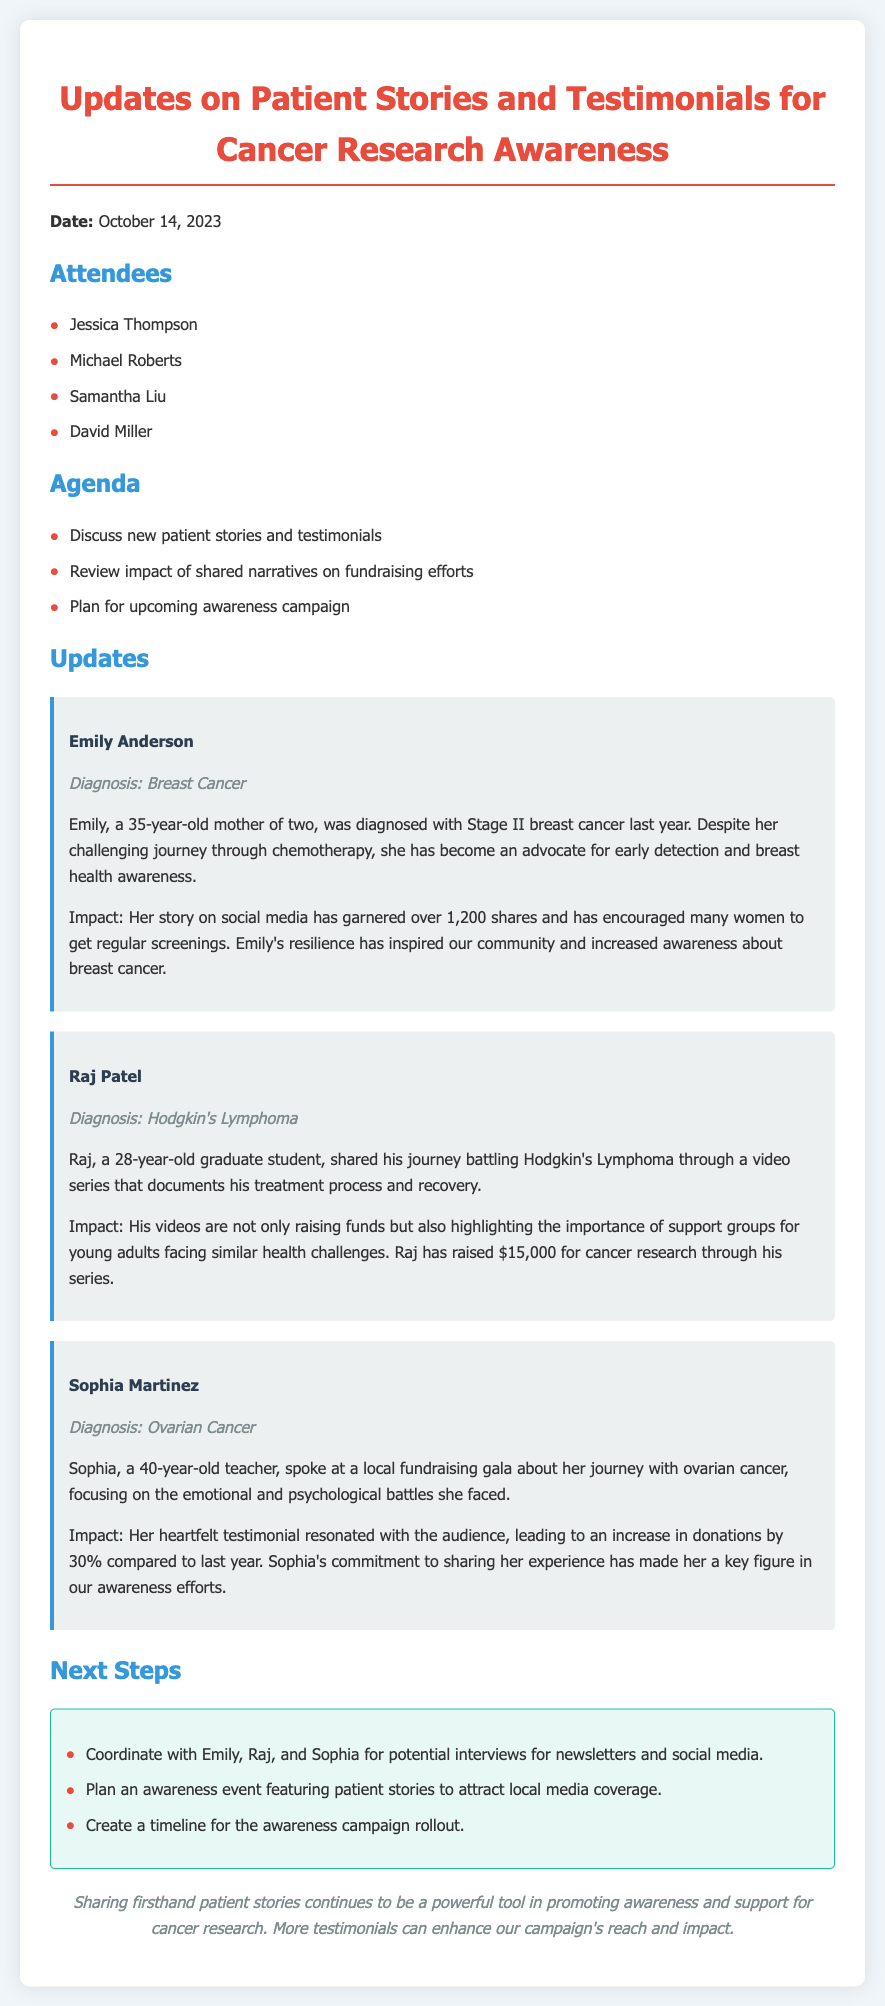What is the date of the meeting? The date of the meeting is mentioned at the beginning of the document.
Answer: October 14, 2023 Who shared their journey battling Hodgkin's Lymphoma? This information is found under the updates section where individual patient stories are detailed.
Answer: Raj Patel What impact did Emily Anderson's story have on social media? The impact of Emily Anderson's story is detailed in her patient story section.
Answer: Over 1,200 shares How much money did Raj raise for cancer research? This information is provided in Raj Patel's patient story regarding the financial outcome of his video series.
Answer: $15,000 Which patient was diagnosed with ovarian cancer? This can be identified from the individual patient stories listed in the updates.
Answer: Sophia Martinez What type of event is being planned for awareness? This question pertains to the next steps outlined in the document regarding the awareness campaign.
Answer: An awareness event What was the percentage increase in donations after Sophia's testimonial? This information is found in Sophia’s patient story detailing the outcome of her speech at the gala.
Answer: 30% What are the next steps mentioned for patient interviews? This can be determined from the 'Next Steps' section addressing coordination with patients.
Answer: Coordinate with Emily, Raj, and Sophia for interviews 